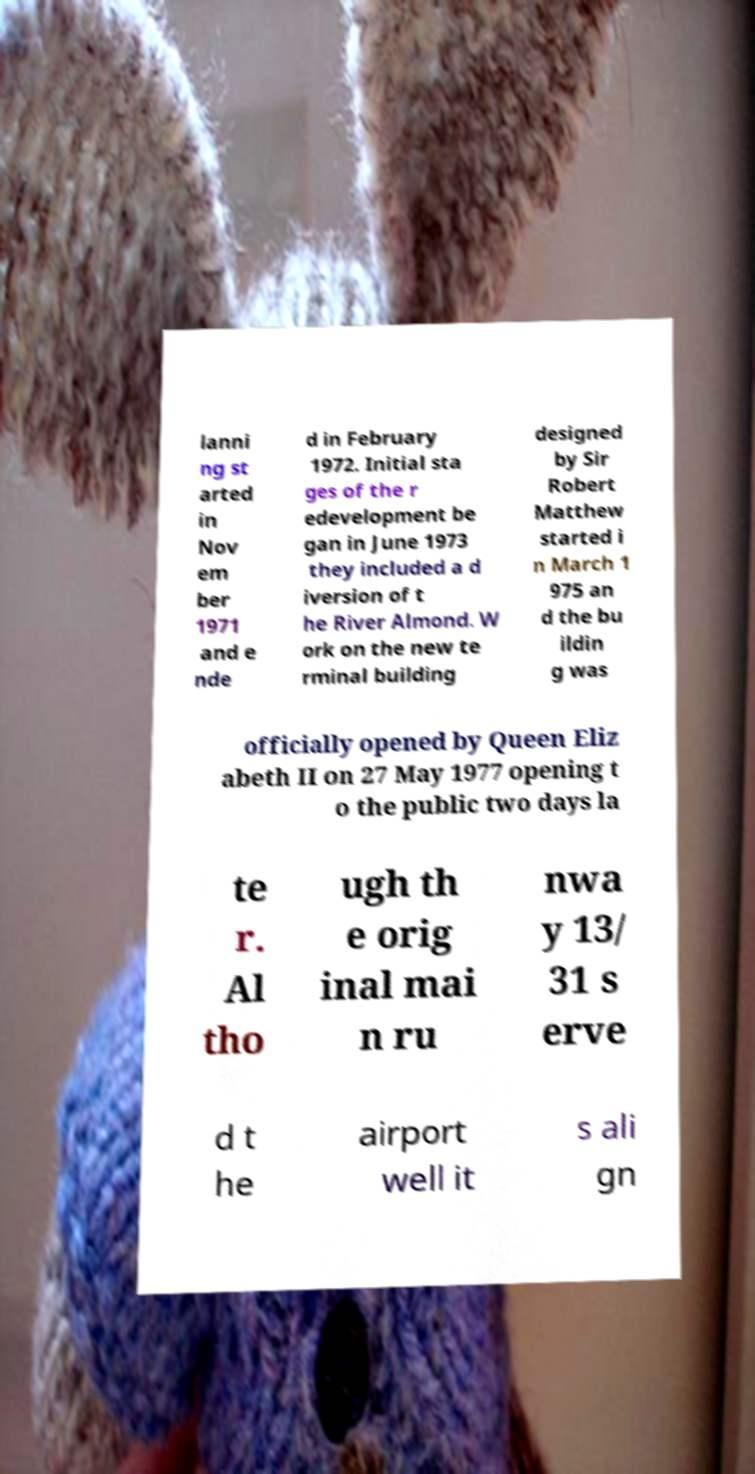Could you extract and type out the text from this image? lanni ng st arted in Nov em ber 1971 and e nde d in February 1972. Initial sta ges of the r edevelopment be gan in June 1973 they included a d iversion of t he River Almond. W ork on the new te rminal building designed by Sir Robert Matthew started i n March 1 975 an d the bu ildin g was officially opened by Queen Eliz abeth II on 27 May 1977 opening t o the public two days la te r. Al tho ugh th e orig inal mai n ru nwa y 13/ 31 s erve d t he airport well it s ali gn 